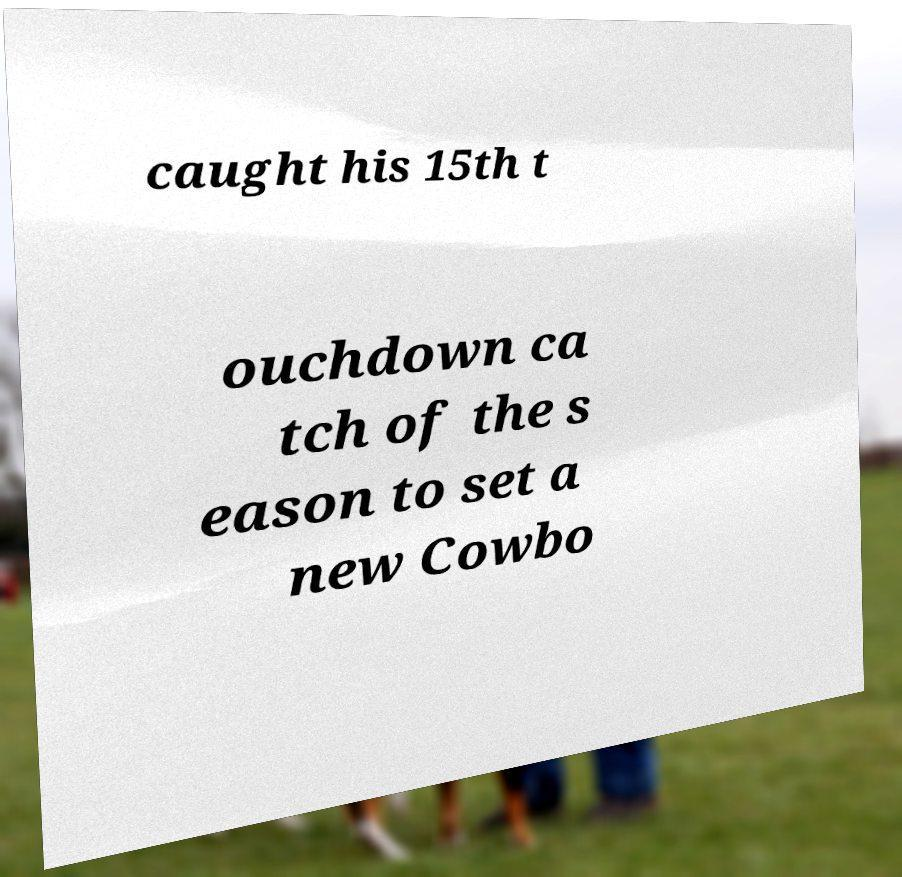I need the written content from this picture converted into text. Can you do that? caught his 15th t ouchdown ca tch of the s eason to set a new Cowbo 